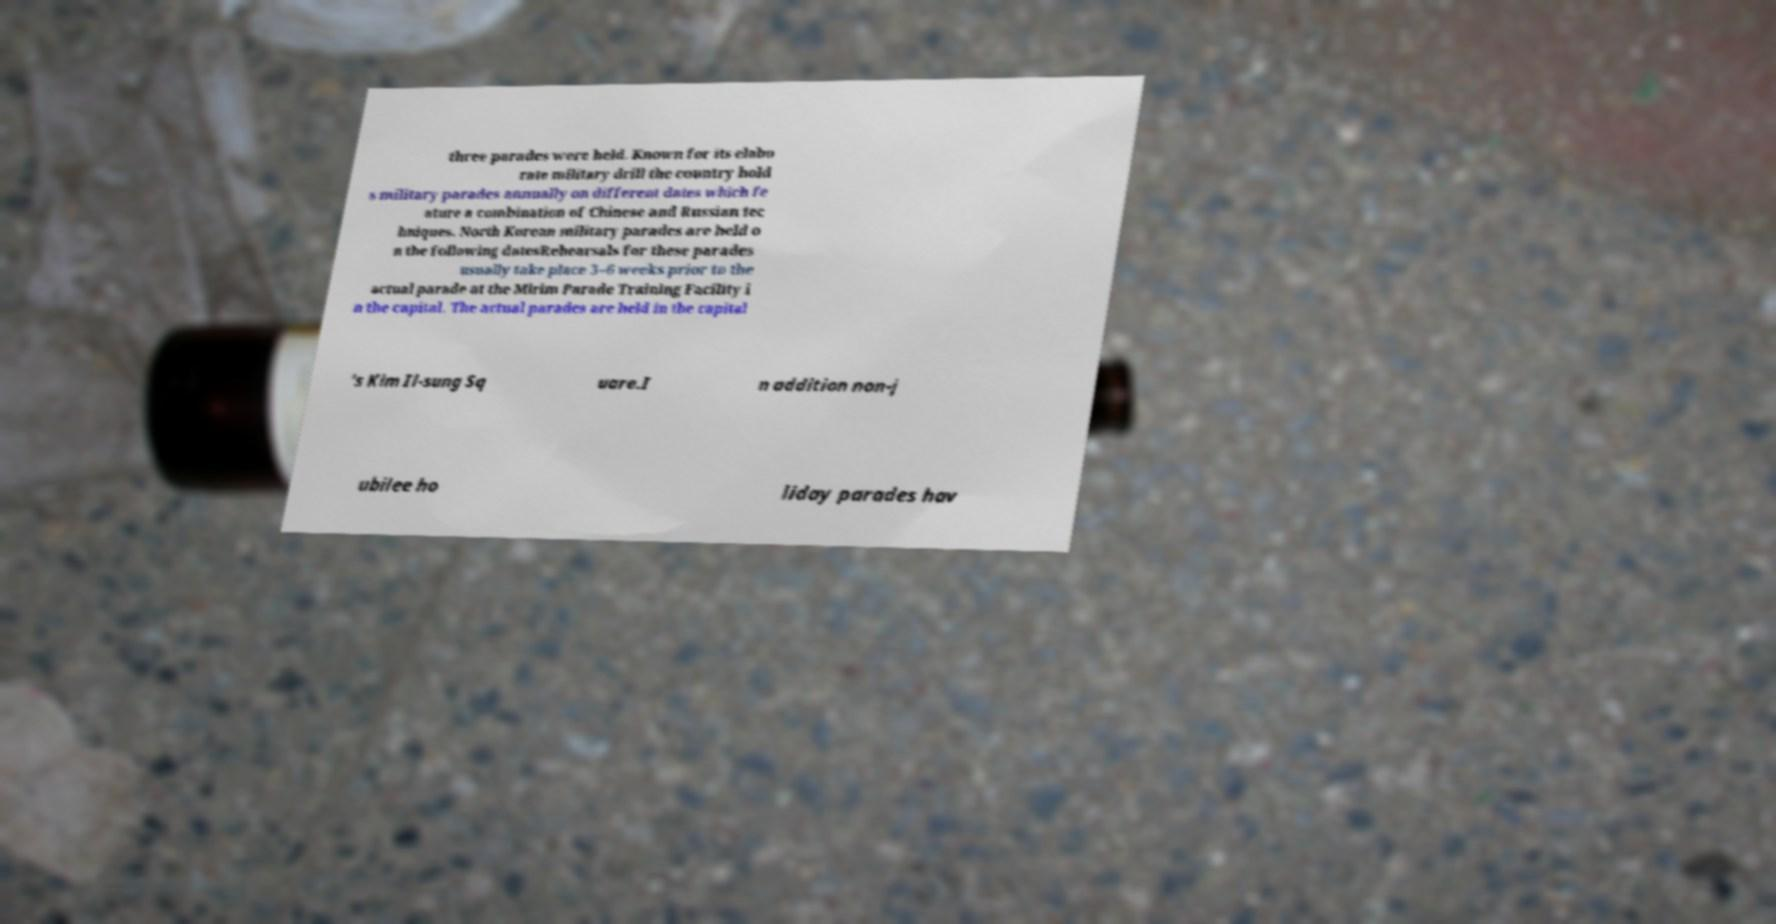Can you accurately transcribe the text from the provided image for me? three parades were held. Known for its elabo rate military drill the country hold s military parades annually on different dates which fe ature a combination of Chinese and Russian tec hniques. North Korean military parades are held o n the following datesRehearsals for these parades usually take place 3–6 weeks prior to the actual parade at the Mirim Parade Training Facility i n the capital. The actual parades are held in the capital 's Kim Il-sung Sq uare.I n addition non-j ubilee ho liday parades hav 